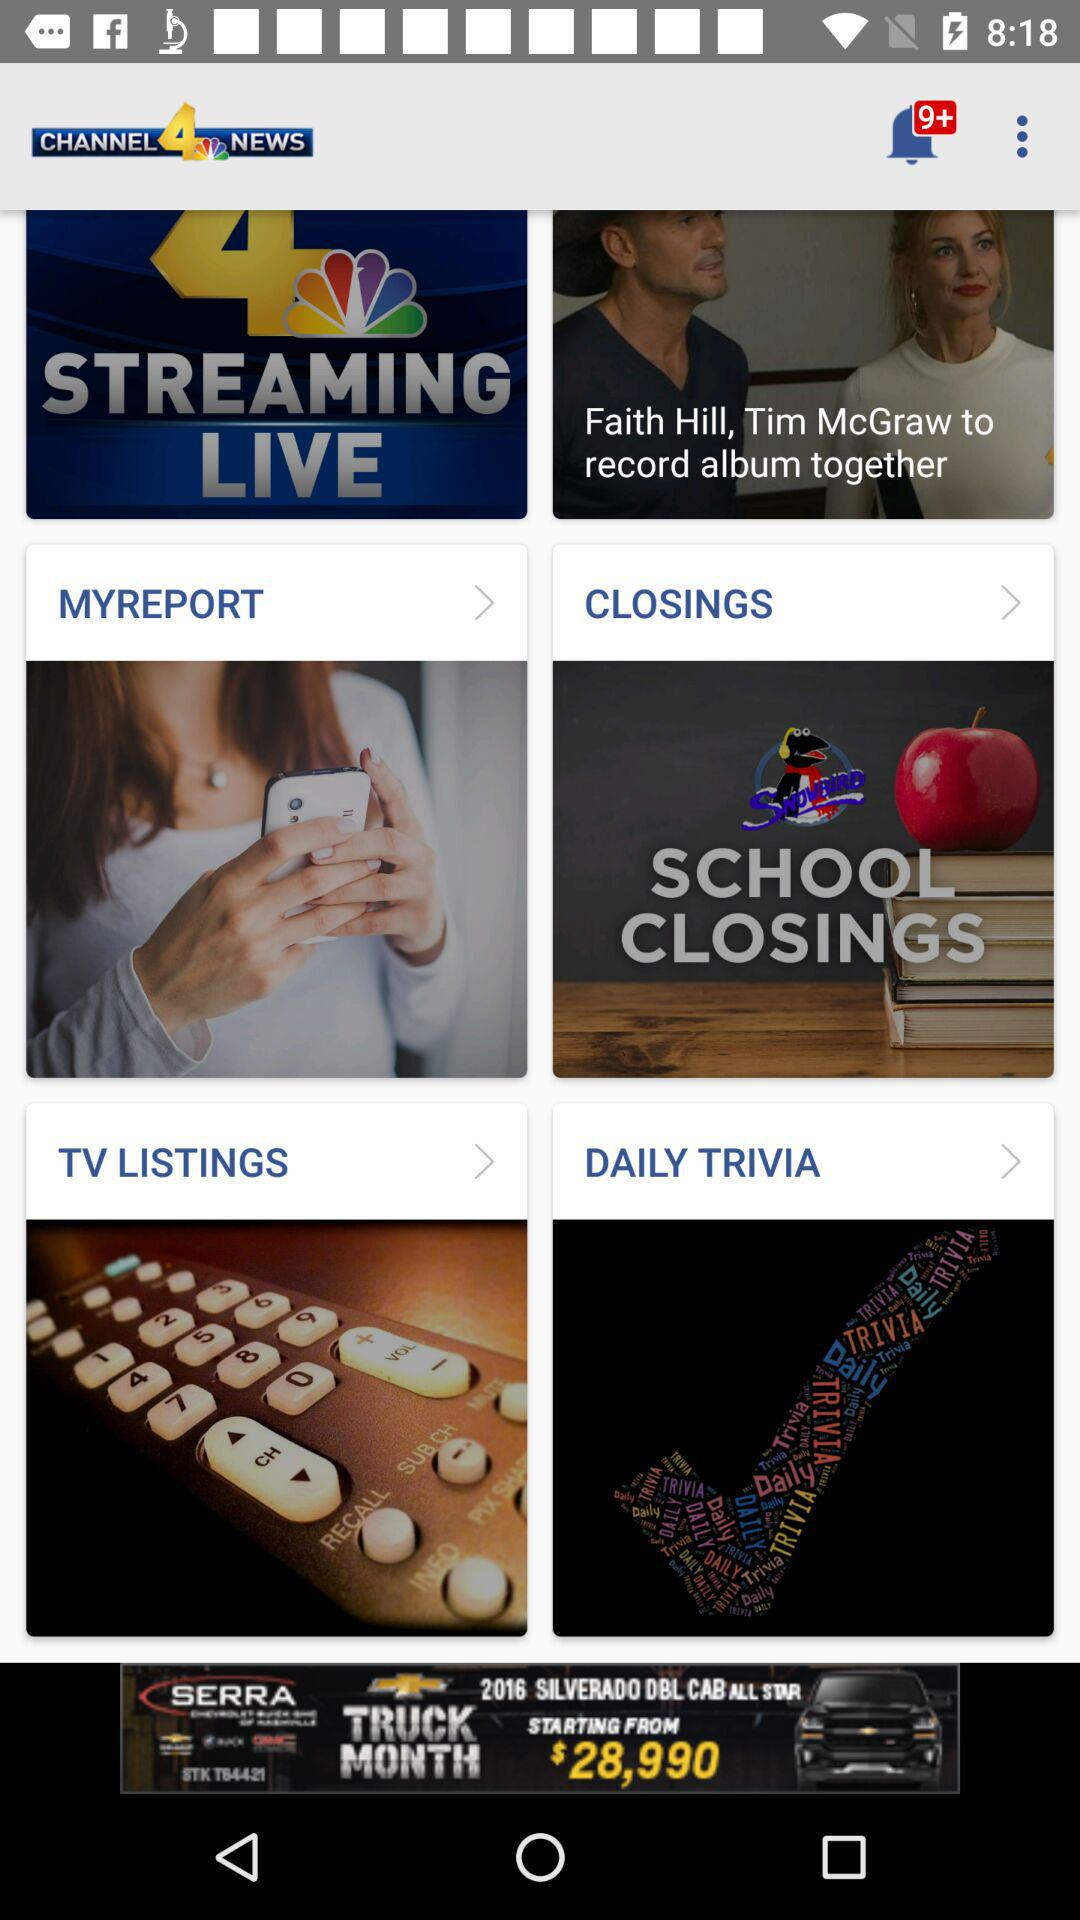What is the name of news channel?
When the provided information is insufficient, respond with <no answer>. <no answer> 